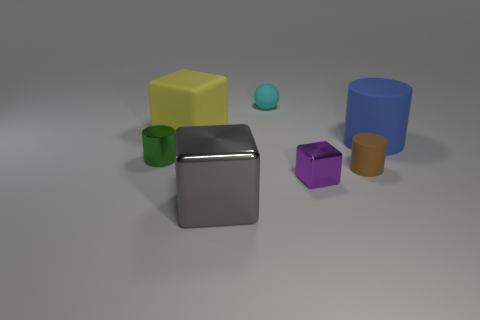Can you describe the texture of the objects? Certainly, the objects have a variety of textures. The gray shiny cube has a smooth and reflective surface, indicating a metallic texture. The other objects, including the yellow cube, the green cylinder, and the blue cylinder, have a matte finish which suggests a plastic or painted wood texture. Do the objects share a common theme or category? Yes, all the objects share the common theme of being geometric shapes, potentially used for educational purposes such as teaching about shapes, volumes, or for spatial reasoning practice. 